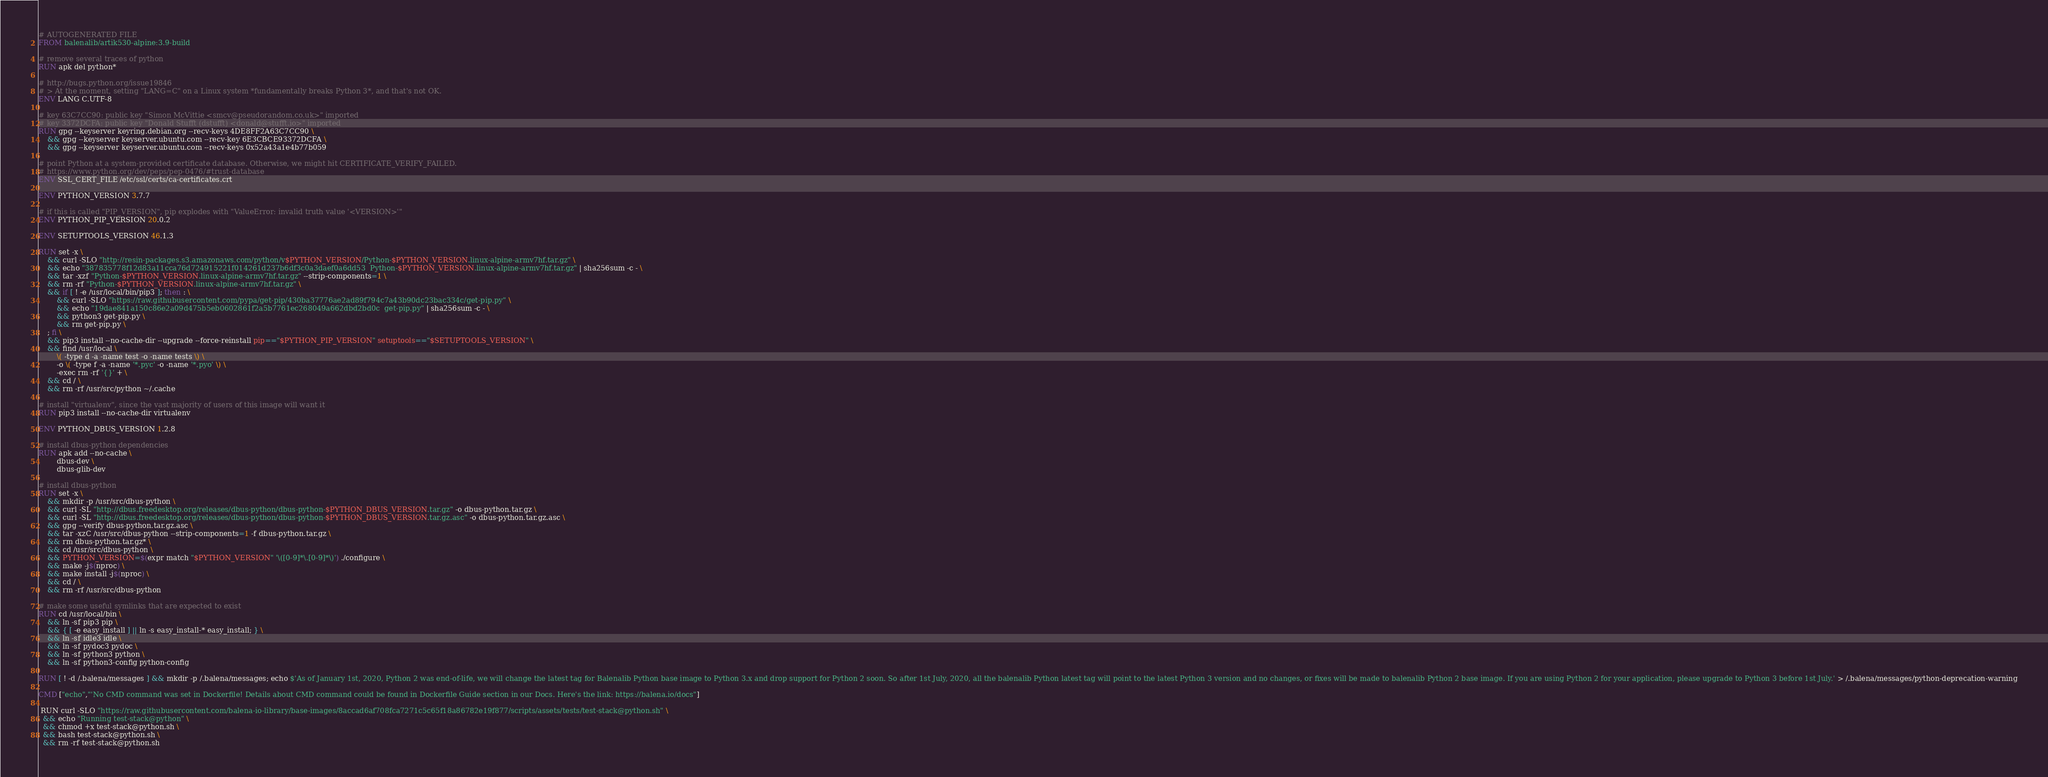<code> <loc_0><loc_0><loc_500><loc_500><_Dockerfile_># AUTOGENERATED FILE
FROM balenalib/artik530-alpine:3.9-build

# remove several traces of python
RUN apk del python*

# http://bugs.python.org/issue19846
# > At the moment, setting "LANG=C" on a Linux system *fundamentally breaks Python 3*, and that's not OK.
ENV LANG C.UTF-8

# key 63C7CC90: public key "Simon McVittie <smcv@pseudorandom.co.uk>" imported
# key 3372DCFA: public key "Donald Stufft (dstufft) <donald@stufft.io>" imported
RUN gpg --keyserver keyring.debian.org --recv-keys 4DE8FF2A63C7CC90 \
	&& gpg --keyserver keyserver.ubuntu.com --recv-key 6E3CBCE93372DCFA \
	&& gpg --keyserver keyserver.ubuntu.com --recv-keys 0x52a43a1e4b77b059

# point Python at a system-provided certificate database. Otherwise, we might hit CERTIFICATE_VERIFY_FAILED.
# https://www.python.org/dev/peps/pep-0476/#trust-database
ENV SSL_CERT_FILE /etc/ssl/certs/ca-certificates.crt

ENV PYTHON_VERSION 3.7.7

# if this is called "PIP_VERSION", pip explodes with "ValueError: invalid truth value '<VERSION>'"
ENV PYTHON_PIP_VERSION 20.0.2

ENV SETUPTOOLS_VERSION 46.1.3

RUN set -x \
	&& curl -SLO "http://resin-packages.s3.amazonaws.com/python/v$PYTHON_VERSION/Python-$PYTHON_VERSION.linux-alpine-armv7hf.tar.gz" \
	&& echo "387835778f12d83a11cca76d724915221f014261d237b6df3c0a3daef0a6dd53  Python-$PYTHON_VERSION.linux-alpine-armv7hf.tar.gz" | sha256sum -c - \
	&& tar -xzf "Python-$PYTHON_VERSION.linux-alpine-armv7hf.tar.gz" --strip-components=1 \
	&& rm -rf "Python-$PYTHON_VERSION.linux-alpine-armv7hf.tar.gz" \
	&& if [ ! -e /usr/local/bin/pip3 ]; then : \
		&& curl -SLO "https://raw.githubusercontent.com/pypa/get-pip/430ba37776ae2ad89f794c7a43b90dc23bac334c/get-pip.py" \
		&& echo "19dae841a150c86e2a09d475b5eb0602861f2a5b7761ec268049a662dbd2bd0c  get-pip.py" | sha256sum -c - \
		&& python3 get-pip.py \
		&& rm get-pip.py \
	; fi \
	&& pip3 install --no-cache-dir --upgrade --force-reinstall pip=="$PYTHON_PIP_VERSION" setuptools=="$SETUPTOOLS_VERSION" \
	&& find /usr/local \
		\( -type d -a -name test -o -name tests \) \
		-o \( -type f -a -name '*.pyc' -o -name '*.pyo' \) \
		-exec rm -rf '{}' + \
	&& cd / \
	&& rm -rf /usr/src/python ~/.cache

# install "virtualenv", since the vast majority of users of this image will want it
RUN pip3 install --no-cache-dir virtualenv

ENV PYTHON_DBUS_VERSION 1.2.8

# install dbus-python dependencies 
RUN apk add --no-cache \
		dbus-dev \
		dbus-glib-dev

# install dbus-python
RUN set -x \
	&& mkdir -p /usr/src/dbus-python \
	&& curl -SL "http://dbus.freedesktop.org/releases/dbus-python/dbus-python-$PYTHON_DBUS_VERSION.tar.gz" -o dbus-python.tar.gz \
	&& curl -SL "http://dbus.freedesktop.org/releases/dbus-python/dbus-python-$PYTHON_DBUS_VERSION.tar.gz.asc" -o dbus-python.tar.gz.asc \
	&& gpg --verify dbus-python.tar.gz.asc \
	&& tar -xzC /usr/src/dbus-python --strip-components=1 -f dbus-python.tar.gz \
	&& rm dbus-python.tar.gz* \
	&& cd /usr/src/dbus-python \
	&& PYTHON_VERSION=$(expr match "$PYTHON_VERSION" '\([0-9]*\.[0-9]*\)') ./configure \
	&& make -j$(nproc) \
	&& make install -j$(nproc) \
	&& cd / \
	&& rm -rf /usr/src/dbus-python

# make some useful symlinks that are expected to exist
RUN cd /usr/local/bin \
	&& ln -sf pip3 pip \
	&& { [ -e easy_install ] || ln -s easy_install-* easy_install; } \
	&& ln -sf idle3 idle \
	&& ln -sf pydoc3 pydoc \
	&& ln -sf python3 python \
	&& ln -sf python3-config python-config

RUN [ ! -d /.balena/messages ] && mkdir -p /.balena/messages; echo $'As of January 1st, 2020, Python 2 was end-of-life, we will change the latest tag for Balenalib Python base image to Python 3.x and drop support for Python 2 soon. So after 1st July, 2020, all the balenalib Python latest tag will point to the latest Python 3 version and no changes, or fixes will be made to balenalib Python 2 base image. If you are using Python 2 for your application, please upgrade to Python 3 before 1st July.' > /.balena/messages/python-deprecation-warning

CMD ["echo","'No CMD command was set in Dockerfile! Details about CMD command could be found in Dockerfile Guide section in our Docs. Here's the link: https://balena.io/docs"]

 RUN curl -SLO "https://raw.githubusercontent.com/balena-io-library/base-images/8accad6af708fca7271c5c65f18a86782e19f877/scripts/assets/tests/test-stack@python.sh" \
  && echo "Running test-stack@python" \
  && chmod +x test-stack@python.sh \
  && bash test-stack@python.sh \
  && rm -rf test-stack@python.sh 
</code> 